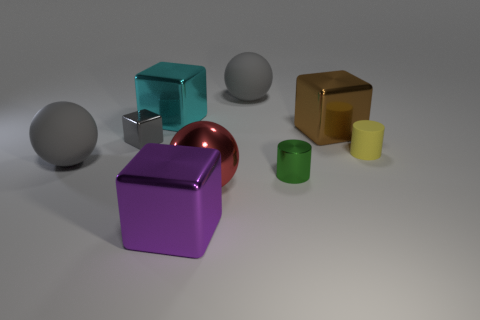Add 1 tiny brown rubber spheres. How many objects exist? 10 Subtract all cylinders. How many objects are left? 7 Add 3 large cyan metallic blocks. How many large cyan metallic blocks are left? 4 Add 1 big cyan rubber cylinders. How many big cyan rubber cylinders exist? 1 Subtract 0 brown cylinders. How many objects are left? 9 Subtract all big cylinders. Subtract all green metallic things. How many objects are left? 8 